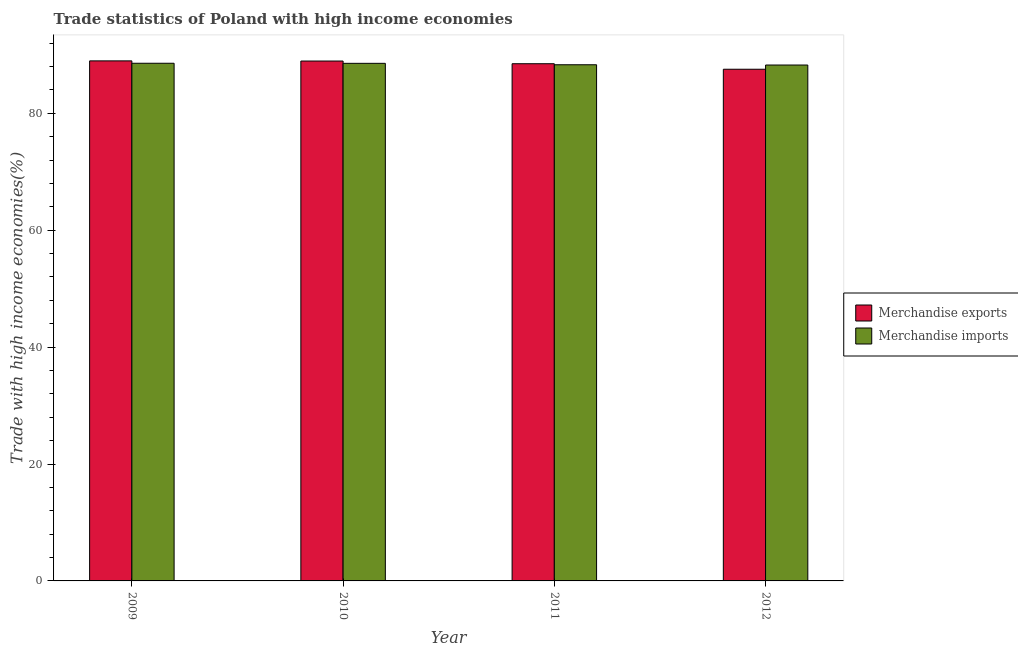How many different coloured bars are there?
Your response must be concise. 2. Are the number of bars per tick equal to the number of legend labels?
Offer a terse response. Yes. What is the merchandise exports in 2011?
Make the answer very short. 88.48. Across all years, what is the maximum merchandise exports?
Offer a terse response. 88.97. Across all years, what is the minimum merchandise exports?
Provide a short and direct response. 87.54. In which year was the merchandise imports maximum?
Your response must be concise. 2009. What is the total merchandise imports in the graph?
Provide a short and direct response. 353.67. What is the difference between the merchandise exports in 2009 and that in 2012?
Keep it short and to the point. 1.43. What is the difference between the merchandise exports in 2011 and the merchandise imports in 2009?
Provide a short and direct response. -0.49. What is the average merchandise imports per year?
Your answer should be compact. 88.42. In the year 2012, what is the difference between the merchandise imports and merchandise exports?
Your answer should be very brief. 0. What is the ratio of the merchandise imports in 2011 to that in 2012?
Offer a very short reply. 1. Is the merchandise imports in 2009 less than that in 2012?
Offer a terse response. No. What is the difference between the highest and the second highest merchandise imports?
Provide a short and direct response. 0.01. What is the difference between the highest and the lowest merchandise imports?
Your answer should be very brief. 0.3. Is the sum of the merchandise exports in 2010 and 2011 greater than the maximum merchandise imports across all years?
Keep it short and to the point. Yes. What does the 2nd bar from the left in 2010 represents?
Ensure brevity in your answer.  Merchandise imports. What does the 1st bar from the right in 2011 represents?
Ensure brevity in your answer.  Merchandise imports. How many bars are there?
Your answer should be compact. 8. Are all the bars in the graph horizontal?
Your response must be concise. No. How many years are there in the graph?
Provide a succinct answer. 4. Are the values on the major ticks of Y-axis written in scientific E-notation?
Your answer should be very brief. No. Does the graph contain any zero values?
Your answer should be compact. No. Does the graph contain grids?
Keep it short and to the point. No. Where does the legend appear in the graph?
Provide a succinct answer. Center right. How are the legend labels stacked?
Your answer should be very brief. Vertical. What is the title of the graph?
Make the answer very short. Trade statistics of Poland with high income economies. Does "Non-resident workers" appear as one of the legend labels in the graph?
Make the answer very short. No. What is the label or title of the Y-axis?
Provide a succinct answer. Trade with high income economies(%). What is the Trade with high income economies(%) in Merchandise exports in 2009?
Make the answer very short. 88.97. What is the Trade with high income economies(%) of Merchandise imports in 2009?
Provide a succinct answer. 88.56. What is the Trade with high income economies(%) of Merchandise exports in 2010?
Ensure brevity in your answer.  88.94. What is the Trade with high income economies(%) in Merchandise imports in 2010?
Make the answer very short. 88.55. What is the Trade with high income economies(%) in Merchandise exports in 2011?
Your answer should be very brief. 88.48. What is the Trade with high income economies(%) of Merchandise imports in 2011?
Make the answer very short. 88.3. What is the Trade with high income economies(%) in Merchandise exports in 2012?
Provide a succinct answer. 87.54. What is the Trade with high income economies(%) of Merchandise imports in 2012?
Make the answer very short. 88.26. Across all years, what is the maximum Trade with high income economies(%) of Merchandise exports?
Your answer should be compact. 88.97. Across all years, what is the maximum Trade with high income economies(%) in Merchandise imports?
Offer a very short reply. 88.56. Across all years, what is the minimum Trade with high income economies(%) of Merchandise exports?
Your answer should be compact. 87.54. Across all years, what is the minimum Trade with high income economies(%) of Merchandise imports?
Provide a short and direct response. 88.26. What is the total Trade with high income economies(%) of Merchandise exports in the graph?
Keep it short and to the point. 353.93. What is the total Trade with high income economies(%) in Merchandise imports in the graph?
Give a very brief answer. 353.67. What is the difference between the Trade with high income economies(%) in Merchandise exports in 2009 and that in 2010?
Provide a short and direct response. 0.03. What is the difference between the Trade with high income economies(%) in Merchandise imports in 2009 and that in 2010?
Your response must be concise. 0.01. What is the difference between the Trade with high income economies(%) of Merchandise exports in 2009 and that in 2011?
Your answer should be compact. 0.49. What is the difference between the Trade with high income economies(%) of Merchandise imports in 2009 and that in 2011?
Make the answer very short. 0.26. What is the difference between the Trade with high income economies(%) of Merchandise exports in 2009 and that in 2012?
Provide a short and direct response. 1.43. What is the difference between the Trade with high income economies(%) in Merchandise imports in 2009 and that in 2012?
Provide a succinct answer. 0.3. What is the difference between the Trade with high income economies(%) of Merchandise exports in 2010 and that in 2011?
Offer a terse response. 0.46. What is the difference between the Trade with high income economies(%) in Merchandise imports in 2010 and that in 2011?
Give a very brief answer. 0.24. What is the difference between the Trade with high income economies(%) of Merchandise exports in 2010 and that in 2012?
Offer a very short reply. 1.4. What is the difference between the Trade with high income economies(%) of Merchandise imports in 2010 and that in 2012?
Your response must be concise. 0.29. What is the difference between the Trade with high income economies(%) in Merchandise exports in 2011 and that in 2012?
Keep it short and to the point. 0.94. What is the difference between the Trade with high income economies(%) in Merchandise imports in 2011 and that in 2012?
Keep it short and to the point. 0.04. What is the difference between the Trade with high income economies(%) of Merchandise exports in 2009 and the Trade with high income economies(%) of Merchandise imports in 2010?
Provide a succinct answer. 0.42. What is the difference between the Trade with high income economies(%) in Merchandise exports in 2009 and the Trade with high income economies(%) in Merchandise imports in 2011?
Make the answer very short. 0.67. What is the difference between the Trade with high income economies(%) of Merchandise exports in 2009 and the Trade with high income economies(%) of Merchandise imports in 2012?
Your response must be concise. 0.71. What is the difference between the Trade with high income economies(%) in Merchandise exports in 2010 and the Trade with high income economies(%) in Merchandise imports in 2011?
Your response must be concise. 0.64. What is the difference between the Trade with high income economies(%) of Merchandise exports in 2010 and the Trade with high income economies(%) of Merchandise imports in 2012?
Make the answer very short. 0.68. What is the difference between the Trade with high income economies(%) of Merchandise exports in 2011 and the Trade with high income economies(%) of Merchandise imports in 2012?
Your answer should be compact. 0.22. What is the average Trade with high income economies(%) in Merchandise exports per year?
Keep it short and to the point. 88.48. What is the average Trade with high income economies(%) of Merchandise imports per year?
Give a very brief answer. 88.42. In the year 2009, what is the difference between the Trade with high income economies(%) in Merchandise exports and Trade with high income economies(%) in Merchandise imports?
Ensure brevity in your answer.  0.41. In the year 2010, what is the difference between the Trade with high income economies(%) in Merchandise exports and Trade with high income economies(%) in Merchandise imports?
Keep it short and to the point. 0.39. In the year 2011, what is the difference between the Trade with high income economies(%) of Merchandise exports and Trade with high income economies(%) of Merchandise imports?
Ensure brevity in your answer.  0.18. In the year 2012, what is the difference between the Trade with high income economies(%) of Merchandise exports and Trade with high income economies(%) of Merchandise imports?
Provide a short and direct response. -0.72. What is the ratio of the Trade with high income economies(%) in Merchandise exports in 2009 to that in 2010?
Provide a short and direct response. 1. What is the ratio of the Trade with high income economies(%) of Merchandise imports in 2009 to that in 2010?
Offer a very short reply. 1. What is the ratio of the Trade with high income economies(%) in Merchandise imports in 2009 to that in 2011?
Give a very brief answer. 1. What is the ratio of the Trade with high income economies(%) in Merchandise exports in 2009 to that in 2012?
Give a very brief answer. 1.02. What is the ratio of the Trade with high income economies(%) in Merchandise imports in 2009 to that in 2012?
Make the answer very short. 1. What is the ratio of the Trade with high income economies(%) of Merchandise imports in 2010 to that in 2011?
Your answer should be very brief. 1. What is the ratio of the Trade with high income economies(%) in Merchandise exports in 2011 to that in 2012?
Ensure brevity in your answer.  1.01. What is the ratio of the Trade with high income economies(%) in Merchandise imports in 2011 to that in 2012?
Your answer should be very brief. 1. What is the difference between the highest and the second highest Trade with high income economies(%) in Merchandise exports?
Provide a short and direct response. 0.03. What is the difference between the highest and the second highest Trade with high income economies(%) of Merchandise imports?
Keep it short and to the point. 0.01. What is the difference between the highest and the lowest Trade with high income economies(%) in Merchandise exports?
Your answer should be very brief. 1.43. What is the difference between the highest and the lowest Trade with high income economies(%) in Merchandise imports?
Ensure brevity in your answer.  0.3. 